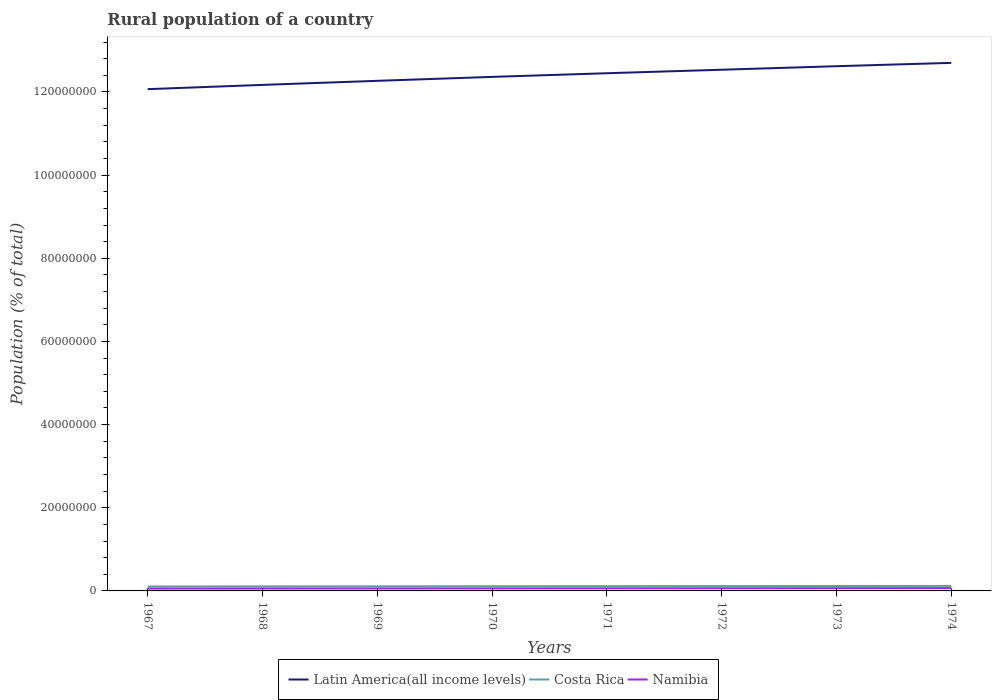How many different coloured lines are there?
Your answer should be very brief. 3. Is the number of lines equal to the number of legend labels?
Offer a very short reply. Yes. Across all years, what is the maximum rural population in Latin America(all income levels)?
Offer a very short reply. 1.21e+08. In which year was the rural population in Costa Rica maximum?
Offer a very short reply. 1967. What is the total rural population in Costa Rica in the graph?
Offer a terse response. -7.58e+04. What is the difference between the highest and the second highest rural population in Costa Rica?
Keep it short and to the point. 1.39e+05. What is the difference between the highest and the lowest rural population in Costa Rica?
Provide a short and direct response. 4. How many years are there in the graph?
Ensure brevity in your answer.  8. What is the difference between two consecutive major ticks on the Y-axis?
Your response must be concise. 2.00e+07. Are the values on the major ticks of Y-axis written in scientific E-notation?
Make the answer very short. No. How are the legend labels stacked?
Ensure brevity in your answer.  Horizontal. What is the title of the graph?
Your answer should be very brief. Rural population of a country. Does "Egypt, Arab Rep." appear as one of the legend labels in the graph?
Your answer should be compact. No. What is the label or title of the Y-axis?
Ensure brevity in your answer.  Population (% of total). What is the Population (% of total) in Latin America(all income levels) in 1967?
Make the answer very short. 1.21e+08. What is the Population (% of total) of Costa Rica in 1967?
Your response must be concise. 1.07e+06. What is the Population (% of total) of Namibia in 1967?
Provide a short and direct response. 5.68e+05. What is the Population (% of total) of Latin America(all income levels) in 1968?
Offer a very short reply. 1.22e+08. What is the Population (% of total) in Costa Rica in 1968?
Give a very brief answer. 1.09e+06. What is the Population (% of total) of Namibia in 1968?
Your answer should be compact. 5.80e+05. What is the Population (% of total) of Latin America(all income levels) in 1969?
Make the answer very short. 1.23e+08. What is the Population (% of total) of Costa Rica in 1969?
Give a very brief answer. 1.11e+06. What is the Population (% of total) in Namibia in 1969?
Provide a short and direct response. 5.93e+05. What is the Population (% of total) in Latin America(all income levels) in 1970?
Ensure brevity in your answer.  1.24e+08. What is the Population (% of total) of Costa Rica in 1970?
Offer a terse response. 1.13e+06. What is the Population (% of total) of Namibia in 1970?
Make the answer very short. 6.06e+05. What is the Population (% of total) of Latin America(all income levels) in 1971?
Ensure brevity in your answer.  1.25e+08. What is the Population (% of total) of Costa Rica in 1971?
Provide a succinct answer. 1.15e+06. What is the Population (% of total) in Namibia in 1971?
Give a very brief answer. 6.23e+05. What is the Population (% of total) of Latin America(all income levels) in 1972?
Your answer should be very brief. 1.25e+08. What is the Population (% of total) in Costa Rica in 1972?
Your answer should be very brief. 1.17e+06. What is the Population (% of total) in Namibia in 1972?
Your response must be concise. 6.40e+05. What is the Population (% of total) in Latin America(all income levels) in 1973?
Provide a short and direct response. 1.26e+08. What is the Population (% of total) of Costa Rica in 1973?
Provide a succinct answer. 1.18e+06. What is the Population (% of total) of Namibia in 1973?
Offer a terse response. 6.58e+05. What is the Population (% of total) of Latin America(all income levels) in 1974?
Provide a short and direct response. 1.27e+08. What is the Population (% of total) of Costa Rica in 1974?
Keep it short and to the point. 1.21e+06. What is the Population (% of total) of Namibia in 1974?
Offer a very short reply. 6.75e+05. Across all years, what is the maximum Population (% of total) in Latin America(all income levels)?
Offer a terse response. 1.27e+08. Across all years, what is the maximum Population (% of total) of Costa Rica?
Make the answer very short. 1.21e+06. Across all years, what is the maximum Population (% of total) in Namibia?
Offer a very short reply. 6.75e+05. Across all years, what is the minimum Population (% of total) in Latin America(all income levels)?
Give a very brief answer. 1.21e+08. Across all years, what is the minimum Population (% of total) of Costa Rica?
Your answer should be compact. 1.07e+06. Across all years, what is the minimum Population (% of total) of Namibia?
Keep it short and to the point. 5.68e+05. What is the total Population (% of total) of Latin America(all income levels) in the graph?
Give a very brief answer. 9.92e+08. What is the total Population (% of total) of Costa Rica in the graph?
Offer a terse response. 9.11e+06. What is the total Population (% of total) of Namibia in the graph?
Provide a succinct answer. 4.94e+06. What is the difference between the Population (% of total) in Latin America(all income levels) in 1967 and that in 1968?
Keep it short and to the point. -1.03e+06. What is the difference between the Population (% of total) of Costa Rica in 1967 and that in 1968?
Provide a short and direct response. -2.22e+04. What is the difference between the Population (% of total) in Namibia in 1967 and that in 1968?
Give a very brief answer. -1.18e+04. What is the difference between the Population (% of total) of Latin America(all income levels) in 1967 and that in 1969?
Your answer should be very brief. -2.01e+06. What is the difference between the Population (% of total) of Costa Rica in 1967 and that in 1969?
Your answer should be compact. -4.34e+04. What is the difference between the Population (% of total) of Namibia in 1967 and that in 1969?
Your answer should be compact. -2.44e+04. What is the difference between the Population (% of total) of Latin America(all income levels) in 1967 and that in 1970?
Make the answer very short. -2.95e+06. What is the difference between the Population (% of total) of Costa Rica in 1967 and that in 1970?
Your response must be concise. -6.32e+04. What is the difference between the Population (% of total) of Namibia in 1967 and that in 1970?
Offer a very short reply. -3.82e+04. What is the difference between the Population (% of total) in Latin America(all income levels) in 1967 and that in 1971?
Your response must be concise. -3.83e+06. What is the difference between the Population (% of total) of Costa Rica in 1967 and that in 1971?
Keep it short and to the point. -8.18e+04. What is the difference between the Population (% of total) of Namibia in 1967 and that in 1971?
Keep it short and to the point. -5.46e+04. What is the difference between the Population (% of total) of Latin America(all income levels) in 1967 and that in 1972?
Offer a very short reply. -4.67e+06. What is the difference between the Population (% of total) of Costa Rica in 1967 and that in 1972?
Keep it short and to the point. -9.91e+04. What is the difference between the Population (% of total) of Namibia in 1967 and that in 1972?
Offer a very short reply. -7.21e+04. What is the difference between the Population (% of total) in Latin America(all income levels) in 1967 and that in 1973?
Provide a short and direct response. -5.52e+06. What is the difference between the Population (% of total) of Costa Rica in 1967 and that in 1973?
Your answer should be compact. -1.17e+05. What is the difference between the Population (% of total) in Namibia in 1967 and that in 1973?
Offer a terse response. -9.00e+04. What is the difference between the Population (% of total) in Latin America(all income levels) in 1967 and that in 1974?
Make the answer very short. -6.33e+06. What is the difference between the Population (% of total) in Costa Rica in 1967 and that in 1974?
Provide a succinct answer. -1.39e+05. What is the difference between the Population (% of total) of Namibia in 1967 and that in 1974?
Your answer should be very brief. -1.07e+05. What is the difference between the Population (% of total) of Latin America(all income levels) in 1968 and that in 1969?
Ensure brevity in your answer.  -9.79e+05. What is the difference between the Population (% of total) of Costa Rica in 1968 and that in 1969?
Your answer should be compact. -2.11e+04. What is the difference between the Population (% of total) in Namibia in 1968 and that in 1969?
Your response must be concise. -1.26e+04. What is the difference between the Population (% of total) of Latin America(all income levels) in 1968 and that in 1970?
Offer a very short reply. -1.93e+06. What is the difference between the Population (% of total) of Costa Rica in 1968 and that in 1970?
Ensure brevity in your answer.  -4.10e+04. What is the difference between the Population (% of total) in Namibia in 1968 and that in 1970?
Provide a succinct answer. -2.64e+04. What is the difference between the Population (% of total) in Latin America(all income levels) in 1968 and that in 1971?
Offer a terse response. -2.81e+06. What is the difference between the Population (% of total) in Costa Rica in 1968 and that in 1971?
Offer a very short reply. -5.95e+04. What is the difference between the Population (% of total) of Namibia in 1968 and that in 1971?
Your answer should be very brief. -4.29e+04. What is the difference between the Population (% of total) in Latin America(all income levels) in 1968 and that in 1972?
Your response must be concise. -3.65e+06. What is the difference between the Population (% of total) of Costa Rica in 1968 and that in 1972?
Your response must be concise. -7.69e+04. What is the difference between the Population (% of total) of Namibia in 1968 and that in 1972?
Make the answer very short. -6.04e+04. What is the difference between the Population (% of total) in Latin America(all income levels) in 1968 and that in 1973?
Your answer should be compact. -4.50e+06. What is the difference between the Population (% of total) in Costa Rica in 1968 and that in 1973?
Make the answer very short. -9.43e+04. What is the difference between the Population (% of total) in Namibia in 1968 and that in 1973?
Give a very brief answer. -7.82e+04. What is the difference between the Population (% of total) in Latin America(all income levels) in 1968 and that in 1974?
Provide a short and direct response. -5.30e+06. What is the difference between the Population (% of total) in Costa Rica in 1968 and that in 1974?
Offer a terse response. -1.17e+05. What is the difference between the Population (% of total) in Namibia in 1968 and that in 1974?
Give a very brief answer. -9.55e+04. What is the difference between the Population (% of total) in Latin America(all income levels) in 1969 and that in 1970?
Offer a terse response. -9.47e+05. What is the difference between the Population (% of total) in Costa Rica in 1969 and that in 1970?
Your answer should be very brief. -1.99e+04. What is the difference between the Population (% of total) of Namibia in 1969 and that in 1970?
Make the answer very short. -1.38e+04. What is the difference between the Population (% of total) of Latin America(all income levels) in 1969 and that in 1971?
Your answer should be very brief. -1.83e+06. What is the difference between the Population (% of total) of Costa Rica in 1969 and that in 1971?
Provide a short and direct response. -3.84e+04. What is the difference between the Population (% of total) of Namibia in 1969 and that in 1971?
Provide a succinct answer. -3.03e+04. What is the difference between the Population (% of total) of Latin America(all income levels) in 1969 and that in 1972?
Your answer should be compact. -2.67e+06. What is the difference between the Population (% of total) in Costa Rica in 1969 and that in 1972?
Give a very brief answer. -5.58e+04. What is the difference between the Population (% of total) in Namibia in 1969 and that in 1972?
Provide a short and direct response. -4.78e+04. What is the difference between the Population (% of total) of Latin America(all income levels) in 1969 and that in 1973?
Provide a short and direct response. -3.52e+06. What is the difference between the Population (% of total) in Costa Rica in 1969 and that in 1973?
Give a very brief answer. -7.32e+04. What is the difference between the Population (% of total) of Namibia in 1969 and that in 1973?
Your answer should be very brief. -6.56e+04. What is the difference between the Population (% of total) in Latin America(all income levels) in 1969 and that in 1974?
Your answer should be compact. -4.32e+06. What is the difference between the Population (% of total) in Costa Rica in 1969 and that in 1974?
Your answer should be very brief. -9.57e+04. What is the difference between the Population (% of total) in Namibia in 1969 and that in 1974?
Make the answer very short. -8.29e+04. What is the difference between the Population (% of total) in Latin America(all income levels) in 1970 and that in 1971?
Your answer should be compact. -8.80e+05. What is the difference between the Population (% of total) of Costa Rica in 1970 and that in 1971?
Keep it short and to the point. -1.85e+04. What is the difference between the Population (% of total) of Namibia in 1970 and that in 1971?
Your answer should be compact. -1.64e+04. What is the difference between the Population (% of total) of Latin America(all income levels) in 1970 and that in 1972?
Provide a succinct answer. -1.72e+06. What is the difference between the Population (% of total) of Costa Rica in 1970 and that in 1972?
Your answer should be very brief. -3.59e+04. What is the difference between the Population (% of total) in Namibia in 1970 and that in 1972?
Keep it short and to the point. -3.39e+04. What is the difference between the Population (% of total) of Latin America(all income levels) in 1970 and that in 1973?
Provide a short and direct response. -2.57e+06. What is the difference between the Population (% of total) of Costa Rica in 1970 and that in 1973?
Ensure brevity in your answer.  -5.34e+04. What is the difference between the Population (% of total) in Namibia in 1970 and that in 1973?
Your answer should be very brief. -5.18e+04. What is the difference between the Population (% of total) in Latin America(all income levels) in 1970 and that in 1974?
Your answer should be very brief. -3.37e+06. What is the difference between the Population (% of total) of Costa Rica in 1970 and that in 1974?
Provide a short and direct response. -7.58e+04. What is the difference between the Population (% of total) of Namibia in 1970 and that in 1974?
Your answer should be compact. -6.91e+04. What is the difference between the Population (% of total) in Latin America(all income levels) in 1971 and that in 1972?
Give a very brief answer. -8.41e+05. What is the difference between the Population (% of total) of Costa Rica in 1971 and that in 1972?
Offer a terse response. -1.73e+04. What is the difference between the Population (% of total) of Namibia in 1971 and that in 1972?
Give a very brief answer. -1.75e+04. What is the difference between the Population (% of total) in Latin America(all income levels) in 1971 and that in 1973?
Your response must be concise. -1.69e+06. What is the difference between the Population (% of total) of Costa Rica in 1971 and that in 1973?
Give a very brief answer. -3.48e+04. What is the difference between the Population (% of total) in Namibia in 1971 and that in 1973?
Provide a succinct answer. -3.54e+04. What is the difference between the Population (% of total) of Latin America(all income levels) in 1971 and that in 1974?
Give a very brief answer. -2.49e+06. What is the difference between the Population (% of total) in Costa Rica in 1971 and that in 1974?
Keep it short and to the point. -5.73e+04. What is the difference between the Population (% of total) in Namibia in 1971 and that in 1974?
Your answer should be compact. -5.26e+04. What is the difference between the Population (% of total) in Latin America(all income levels) in 1972 and that in 1973?
Your answer should be compact. -8.50e+05. What is the difference between the Population (% of total) of Costa Rica in 1972 and that in 1973?
Your answer should be compact. -1.75e+04. What is the difference between the Population (% of total) of Namibia in 1972 and that in 1973?
Your answer should be very brief. -1.79e+04. What is the difference between the Population (% of total) of Latin America(all income levels) in 1972 and that in 1974?
Ensure brevity in your answer.  -1.65e+06. What is the difference between the Population (% of total) of Costa Rica in 1972 and that in 1974?
Provide a short and direct response. -3.99e+04. What is the difference between the Population (% of total) in Namibia in 1972 and that in 1974?
Keep it short and to the point. -3.51e+04. What is the difference between the Population (% of total) in Latin America(all income levels) in 1973 and that in 1974?
Offer a very short reply. -8.03e+05. What is the difference between the Population (% of total) in Costa Rica in 1973 and that in 1974?
Make the answer very short. -2.25e+04. What is the difference between the Population (% of total) of Namibia in 1973 and that in 1974?
Offer a terse response. -1.72e+04. What is the difference between the Population (% of total) of Latin America(all income levels) in 1967 and the Population (% of total) of Costa Rica in 1968?
Your response must be concise. 1.20e+08. What is the difference between the Population (% of total) in Latin America(all income levels) in 1967 and the Population (% of total) in Namibia in 1968?
Your response must be concise. 1.20e+08. What is the difference between the Population (% of total) of Costa Rica in 1967 and the Population (% of total) of Namibia in 1968?
Provide a short and direct response. 4.88e+05. What is the difference between the Population (% of total) in Latin America(all income levels) in 1967 and the Population (% of total) in Costa Rica in 1969?
Give a very brief answer. 1.20e+08. What is the difference between the Population (% of total) of Latin America(all income levels) in 1967 and the Population (% of total) of Namibia in 1969?
Your answer should be compact. 1.20e+08. What is the difference between the Population (% of total) in Costa Rica in 1967 and the Population (% of total) in Namibia in 1969?
Offer a very short reply. 4.75e+05. What is the difference between the Population (% of total) of Latin America(all income levels) in 1967 and the Population (% of total) of Costa Rica in 1970?
Provide a succinct answer. 1.20e+08. What is the difference between the Population (% of total) in Latin America(all income levels) in 1967 and the Population (% of total) in Namibia in 1970?
Provide a short and direct response. 1.20e+08. What is the difference between the Population (% of total) in Costa Rica in 1967 and the Population (% of total) in Namibia in 1970?
Keep it short and to the point. 4.61e+05. What is the difference between the Population (% of total) in Latin America(all income levels) in 1967 and the Population (% of total) in Costa Rica in 1971?
Your answer should be very brief. 1.20e+08. What is the difference between the Population (% of total) of Latin America(all income levels) in 1967 and the Population (% of total) of Namibia in 1971?
Provide a short and direct response. 1.20e+08. What is the difference between the Population (% of total) of Costa Rica in 1967 and the Population (% of total) of Namibia in 1971?
Your answer should be compact. 4.45e+05. What is the difference between the Population (% of total) of Latin America(all income levels) in 1967 and the Population (% of total) of Costa Rica in 1972?
Ensure brevity in your answer.  1.20e+08. What is the difference between the Population (% of total) of Latin America(all income levels) in 1967 and the Population (% of total) of Namibia in 1972?
Offer a very short reply. 1.20e+08. What is the difference between the Population (% of total) of Costa Rica in 1967 and the Population (% of total) of Namibia in 1972?
Give a very brief answer. 4.27e+05. What is the difference between the Population (% of total) in Latin America(all income levels) in 1967 and the Population (% of total) in Costa Rica in 1973?
Your response must be concise. 1.19e+08. What is the difference between the Population (% of total) of Latin America(all income levels) in 1967 and the Population (% of total) of Namibia in 1973?
Provide a succinct answer. 1.20e+08. What is the difference between the Population (% of total) in Costa Rica in 1967 and the Population (% of total) in Namibia in 1973?
Offer a terse response. 4.10e+05. What is the difference between the Population (% of total) in Latin America(all income levels) in 1967 and the Population (% of total) in Costa Rica in 1974?
Ensure brevity in your answer.  1.19e+08. What is the difference between the Population (% of total) of Latin America(all income levels) in 1967 and the Population (% of total) of Namibia in 1974?
Provide a short and direct response. 1.20e+08. What is the difference between the Population (% of total) in Costa Rica in 1967 and the Population (% of total) in Namibia in 1974?
Provide a short and direct response. 3.92e+05. What is the difference between the Population (% of total) of Latin America(all income levels) in 1968 and the Population (% of total) of Costa Rica in 1969?
Give a very brief answer. 1.21e+08. What is the difference between the Population (% of total) in Latin America(all income levels) in 1968 and the Population (% of total) in Namibia in 1969?
Your answer should be very brief. 1.21e+08. What is the difference between the Population (% of total) of Costa Rica in 1968 and the Population (% of total) of Namibia in 1969?
Your answer should be very brief. 4.97e+05. What is the difference between the Population (% of total) in Latin America(all income levels) in 1968 and the Population (% of total) in Costa Rica in 1970?
Give a very brief answer. 1.21e+08. What is the difference between the Population (% of total) of Latin America(all income levels) in 1968 and the Population (% of total) of Namibia in 1970?
Your answer should be very brief. 1.21e+08. What is the difference between the Population (% of total) of Costa Rica in 1968 and the Population (% of total) of Namibia in 1970?
Give a very brief answer. 4.84e+05. What is the difference between the Population (% of total) of Latin America(all income levels) in 1968 and the Population (% of total) of Costa Rica in 1971?
Keep it short and to the point. 1.21e+08. What is the difference between the Population (% of total) in Latin America(all income levels) in 1968 and the Population (% of total) in Namibia in 1971?
Provide a succinct answer. 1.21e+08. What is the difference between the Population (% of total) of Costa Rica in 1968 and the Population (% of total) of Namibia in 1971?
Your answer should be very brief. 4.67e+05. What is the difference between the Population (% of total) in Latin America(all income levels) in 1968 and the Population (% of total) in Costa Rica in 1972?
Your answer should be very brief. 1.21e+08. What is the difference between the Population (% of total) of Latin America(all income levels) in 1968 and the Population (% of total) of Namibia in 1972?
Ensure brevity in your answer.  1.21e+08. What is the difference between the Population (% of total) of Costa Rica in 1968 and the Population (% of total) of Namibia in 1972?
Give a very brief answer. 4.50e+05. What is the difference between the Population (% of total) of Latin America(all income levels) in 1968 and the Population (% of total) of Costa Rica in 1973?
Offer a terse response. 1.21e+08. What is the difference between the Population (% of total) of Latin America(all income levels) in 1968 and the Population (% of total) of Namibia in 1973?
Offer a very short reply. 1.21e+08. What is the difference between the Population (% of total) in Costa Rica in 1968 and the Population (% of total) in Namibia in 1973?
Your answer should be compact. 4.32e+05. What is the difference between the Population (% of total) in Latin America(all income levels) in 1968 and the Population (% of total) in Costa Rica in 1974?
Provide a succinct answer. 1.20e+08. What is the difference between the Population (% of total) of Latin America(all income levels) in 1968 and the Population (% of total) of Namibia in 1974?
Provide a short and direct response. 1.21e+08. What is the difference between the Population (% of total) of Costa Rica in 1968 and the Population (% of total) of Namibia in 1974?
Make the answer very short. 4.15e+05. What is the difference between the Population (% of total) in Latin America(all income levels) in 1969 and the Population (% of total) in Costa Rica in 1970?
Your answer should be very brief. 1.22e+08. What is the difference between the Population (% of total) in Latin America(all income levels) in 1969 and the Population (% of total) in Namibia in 1970?
Offer a terse response. 1.22e+08. What is the difference between the Population (% of total) of Costa Rica in 1969 and the Population (% of total) of Namibia in 1970?
Keep it short and to the point. 5.05e+05. What is the difference between the Population (% of total) in Latin America(all income levels) in 1969 and the Population (% of total) in Costa Rica in 1971?
Give a very brief answer. 1.22e+08. What is the difference between the Population (% of total) of Latin America(all income levels) in 1969 and the Population (% of total) of Namibia in 1971?
Ensure brevity in your answer.  1.22e+08. What is the difference between the Population (% of total) in Costa Rica in 1969 and the Population (% of total) in Namibia in 1971?
Offer a terse response. 4.88e+05. What is the difference between the Population (% of total) of Latin America(all income levels) in 1969 and the Population (% of total) of Costa Rica in 1972?
Your answer should be compact. 1.22e+08. What is the difference between the Population (% of total) of Latin America(all income levels) in 1969 and the Population (% of total) of Namibia in 1972?
Provide a short and direct response. 1.22e+08. What is the difference between the Population (% of total) in Costa Rica in 1969 and the Population (% of total) in Namibia in 1972?
Keep it short and to the point. 4.71e+05. What is the difference between the Population (% of total) of Latin America(all income levels) in 1969 and the Population (% of total) of Costa Rica in 1973?
Offer a very short reply. 1.21e+08. What is the difference between the Population (% of total) of Latin America(all income levels) in 1969 and the Population (% of total) of Namibia in 1973?
Keep it short and to the point. 1.22e+08. What is the difference between the Population (% of total) in Costa Rica in 1969 and the Population (% of total) in Namibia in 1973?
Ensure brevity in your answer.  4.53e+05. What is the difference between the Population (% of total) in Latin America(all income levels) in 1969 and the Population (% of total) in Costa Rica in 1974?
Provide a succinct answer. 1.21e+08. What is the difference between the Population (% of total) of Latin America(all income levels) in 1969 and the Population (% of total) of Namibia in 1974?
Give a very brief answer. 1.22e+08. What is the difference between the Population (% of total) of Costa Rica in 1969 and the Population (% of total) of Namibia in 1974?
Your answer should be compact. 4.36e+05. What is the difference between the Population (% of total) in Latin America(all income levels) in 1970 and the Population (% of total) in Costa Rica in 1971?
Ensure brevity in your answer.  1.22e+08. What is the difference between the Population (% of total) in Latin America(all income levels) in 1970 and the Population (% of total) in Namibia in 1971?
Offer a very short reply. 1.23e+08. What is the difference between the Population (% of total) of Costa Rica in 1970 and the Population (% of total) of Namibia in 1971?
Keep it short and to the point. 5.08e+05. What is the difference between the Population (% of total) of Latin America(all income levels) in 1970 and the Population (% of total) of Costa Rica in 1972?
Give a very brief answer. 1.22e+08. What is the difference between the Population (% of total) in Latin America(all income levels) in 1970 and the Population (% of total) in Namibia in 1972?
Provide a succinct answer. 1.23e+08. What is the difference between the Population (% of total) in Costa Rica in 1970 and the Population (% of total) in Namibia in 1972?
Give a very brief answer. 4.91e+05. What is the difference between the Population (% of total) of Latin America(all income levels) in 1970 and the Population (% of total) of Costa Rica in 1973?
Your answer should be very brief. 1.22e+08. What is the difference between the Population (% of total) of Latin America(all income levels) in 1970 and the Population (% of total) of Namibia in 1973?
Offer a terse response. 1.23e+08. What is the difference between the Population (% of total) in Costa Rica in 1970 and the Population (% of total) in Namibia in 1973?
Ensure brevity in your answer.  4.73e+05. What is the difference between the Population (% of total) of Latin America(all income levels) in 1970 and the Population (% of total) of Costa Rica in 1974?
Offer a terse response. 1.22e+08. What is the difference between the Population (% of total) of Latin America(all income levels) in 1970 and the Population (% of total) of Namibia in 1974?
Ensure brevity in your answer.  1.23e+08. What is the difference between the Population (% of total) in Costa Rica in 1970 and the Population (% of total) in Namibia in 1974?
Provide a short and direct response. 4.56e+05. What is the difference between the Population (% of total) of Latin America(all income levels) in 1971 and the Population (% of total) of Costa Rica in 1972?
Your answer should be compact. 1.23e+08. What is the difference between the Population (% of total) in Latin America(all income levels) in 1971 and the Population (% of total) in Namibia in 1972?
Make the answer very short. 1.24e+08. What is the difference between the Population (% of total) in Costa Rica in 1971 and the Population (% of total) in Namibia in 1972?
Provide a short and direct response. 5.09e+05. What is the difference between the Population (% of total) in Latin America(all income levels) in 1971 and the Population (% of total) in Costa Rica in 1973?
Give a very brief answer. 1.23e+08. What is the difference between the Population (% of total) in Latin America(all income levels) in 1971 and the Population (% of total) in Namibia in 1973?
Provide a short and direct response. 1.24e+08. What is the difference between the Population (% of total) in Costa Rica in 1971 and the Population (% of total) in Namibia in 1973?
Give a very brief answer. 4.91e+05. What is the difference between the Population (% of total) of Latin America(all income levels) in 1971 and the Population (% of total) of Costa Rica in 1974?
Give a very brief answer. 1.23e+08. What is the difference between the Population (% of total) in Latin America(all income levels) in 1971 and the Population (% of total) in Namibia in 1974?
Ensure brevity in your answer.  1.24e+08. What is the difference between the Population (% of total) of Costa Rica in 1971 and the Population (% of total) of Namibia in 1974?
Your answer should be compact. 4.74e+05. What is the difference between the Population (% of total) of Latin America(all income levels) in 1972 and the Population (% of total) of Costa Rica in 1973?
Give a very brief answer. 1.24e+08. What is the difference between the Population (% of total) of Latin America(all income levels) in 1972 and the Population (% of total) of Namibia in 1973?
Your response must be concise. 1.25e+08. What is the difference between the Population (% of total) in Costa Rica in 1972 and the Population (% of total) in Namibia in 1973?
Ensure brevity in your answer.  5.09e+05. What is the difference between the Population (% of total) of Latin America(all income levels) in 1972 and the Population (% of total) of Costa Rica in 1974?
Offer a very short reply. 1.24e+08. What is the difference between the Population (% of total) in Latin America(all income levels) in 1972 and the Population (% of total) in Namibia in 1974?
Provide a short and direct response. 1.25e+08. What is the difference between the Population (% of total) of Costa Rica in 1972 and the Population (% of total) of Namibia in 1974?
Make the answer very short. 4.91e+05. What is the difference between the Population (% of total) of Latin America(all income levels) in 1973 and the Population (% of total) of Costa Rica in 1974?
Provide a short and direct response. 1.25e+08. What is the difference between the Population (% of total) of Latin America(all income levels) in 1973 and the Population (% of total) of Namibia in 1974?
Offer a terse response. 1.26e+08. What is the difference between the Population (% of total) in Costa Rica in 1973 and the Population (% of total) in Namibia in 1974?
Your answer should be very brief. 5.09e+05. What is the average Population (% of total) in Latin America(all income levels) per year?
Your answer should be compact. 1.24e+08. What is the average Population (% of total) of Costa Rica per year?
Your answer should be compact. 1.14e+06. What is the average Population (% of total) in Namibia per year?
Provide a succinct answer. 6.18e+05. In the year 1967, what is the difference between the Population (% of total) of Latin America(all income levels) and Population (% of total) of Costa Rica?
Provide a short and direct response. 1.20e+08. In the year 1967, what is the difference between the Population (% of total) of Latin America(all income levels) and Population (% of total) of Namibia?
Keep it short and to the point. 1.20e+08. In the year 1967, what is the difference between the Population (% of total) of Costa Rica and Population (% of total) of Namibia?
Provide a short and direct response. 5.00e+05. In the year 1968, what is the difference between the Population (% of total) of Latin America(all income levels) and Population (% of total) of Costa Rica?
Make the answer very short. 1.21e+08. In the year 1968, what is the difference between the Population (% of total) of Latin America(all income levels) and Population (% of total) of Namibia?
Your response must be concise. 1.21e+08. In the year 1968, what is the difference between the Population (% of total) in Costa Rica and Population (% of total) in Namibia?
Make the answer very short. 5.10e+05. In the year 1969, what is the difference between the Population (% of total) in Latin America(all income levels) and Population (% of total) in Costa Rica?
Your answer should be compact. 1.22e+08. In the year 1969, what is the difference between the Population (% of total) in Latin America(all income levels) and Population (% of total) in Namibia?
Offer a terse response. 1.22e+08. In the year 1969, what is the difference between the Population (% of total) in Costa Rica and Population (% of total) in Namibia?
Make the answer very short. 5.19e+05. In the year 1970, what is the difference between the Population (% of total) in Latin America(all income levels) and Population (% of total) in Costa Rica?
Give a very brief answer. 1.22e+08. In the year 1970, what is the difference between the Population (% of total) of Latin America(all income levels) and Population (% of total) of Namibia?
Your response must be concise. 1.23e+08. In the year 1970, what is the difference between the Population (% of total) in Costa Rica and Population (% of total) in Namibia?
Give a very brief answer. 5.25e+05. In the year 1971, what is the difference between the Population (% of total) of Latin America(all income levels) and Population (% of total) of Costa Rica?
Make the answer very short. 1.23e+08. In the year 1971, what is the difference between the Population (% of total) of Latin America(all income levels) and Population (% of total) of Namibia?
Offer a very short reply. 1.24e+08. In the year 1971, what is the difference between the Population (% of total) in Costa Rica and Population (% of total) in Namibia?
Your answer should be compact. 5.27e+05. In the year 1972, what is the difference between the Population (% of total) of Latin America(all income levels) and Population (% of total) of Costa Rica?
Provide a short and direct response. 1.24e+08. In the year 1972, what is the difference between the Population (% of total) of Latin America(all income levels) and Population (% of total) of Namibia?
Ensure brevity in your answer.  1.25e+08. In the year 1972, what is the difference between the Population (% of total) of Costa Rica and Population (% of total) of Namibia?
Keep it short and to the point. 5.27e+05. In the year 1973, what is the difference between the Population (% of total) in Latin America(all income levels) and Population (% of total) in Costa Rica?
Your response must be concise. 1.25e+08. In the year 1973, what is the difference between the Population (% of total) of Latin America(all income levels) and Population (% of total) of Namibia?
Your answer should be very brief. 1.26e+08. In the year 1973, what is the difference between the Population (% of total) of Costa Rica and Population (% of total) of Namibia?
Provide a succinct answer. 5.26e+05. In the year 1974, what is the difference between the Population (% of total) of Latin America(all income levels) and Population (% of total) of Costa Rica?
Offer a very short reply. 1.26e+08. In the year 1974, what is the difference between the Population (% of total) in Latin America(all income levels) and Population (% of total) in Namibia?
Make the answer very short. 1.26e+08. In the year 1974, what is the difference between the Population (% of total) in Costa Rica and Population (% of total) in Namibia?
Your answer should be compact. 5.31e+05. What is the ratio of the Population (% of total) in Costa Rica in 1967 to that in 1968?
Give a very brief answer. 0.98. What is the ratio of the Population (% of total) of Namibia in 1967 to that in 1968?
Provide a short and direct response. 0.98. What is the ratio of the Population (% of total) of Latin America(all income levels) in 1967 to that in 1969?
Provide a short and direct response. 0.98. What is the ratio of the Population (% of total) of Costa Rica in 1967 to that in 1969?
Provide a succinct answer. 0.96. What is the ratio of the Population (% of total) of Namibia in 1967 to that in 1969?
Keep it short and to the point. 0.96. What is the ratio of the Population (% of total) of Latin America(all income levels) in 1967 to that in 1970?
Your response must be concise. 0.98. What is the ratio of the Population (% of total) in Costa Rica in 1967 to that in 1970?
Offer a terse response. 0.94. What is the ratio of the Population (% of total) of Namibia in 1967 to that in 1970?
Make the answer very short. 0.94. What is the ratio of the Population (% of total) in Latin America(all income levels) in 1967 to that in 1971?
Offer a very short reply. 0.97. What is the ratio of the Population (% of total) in Costa Rica in 1967 to that in 1971?
Give a very brief answer. 0.93. What is the ratio of the Population (% of total) of Namibia in 1967 to that in 1971?
Offer a terse response. 0.91. What is the ratio of the Population (% of total) of Latin America(all income levels) in 1967 to that in 1972?
Your answer should be compact. 0.96. What is the ratio of the Population (% of total) in Costa Rica in 1967 to that in 1972?
Keep it short and to the point. 0.92. What is the ratio of the Population (% of total) in Namibia in 1967 to that in 1972?
Your answer should be very brief. 0.89. What is the ratio of the Population (% of total) of Latin America(all income levels) in 1967 to that in 1973?
Offer a terse response. 0.96. What is the ratio of the Population (% of total) of Costa Rica in 1967 to that in 1973?
Your answer should be very brief. 0.9. What is the ratio of the Population (% of total) in Namibia in 1967 to that in 1973?
Give a very brief answer. 0.86. What is the ratio of the Population (% of total) in Latin America(all income levels) in 1967 to that in 1974?
Your response must be concise. 0.95. What is the ratio of the Population (% of total) in Costa Rica in 1967 to that in 1974?
Keep it short and to the point. 0.88. What is the ratio of the Population (% of total) in Namibia in 1967 to that in 1974?
Make the answer very short. 0.84. What is the ratio of the Population (% of total) of Namibia in 1968 to that in 1969?
Your response must be concise. 0.98. What is the ratio of the Population (% of total) in Latin America(all income levels) in 1968 to that in 1970?
Make the answer very short. 0.98. What is the ratio of the Population (% of total) in Costa Rica in 1968 to that in 1970?
Your response must be concise. 0.96. What is the ratio of the Population (% of total) in Namibia in 1968 to that in 1970?
Provide a short and direct response. 0.96. What is the ratio of the Population (% of total) in Latin America(all income levels) in 1968 to that in 1971?
Provide a succinct answer. 0.98. What is the ratio of the Population (% of total) in Costa Rica in 1968 to that in 1971?
Keep it short and to the point. 0.95. What is the ratio of the Population (% of total) in Namibia in 1968 to that in 1971?
Offer a terse response. 0.93. What is the ratio of the Population (% of total) in Latin America(all income levels) in 1968 to that in 1972?
Ensure brevity in your answer.  0.97. What is the ratio of the Population (% of total) in Costa Rica in 1968 to that in 1972?
Make the answer very short. 0.93. What is the ratio of the Population (% of total) in Namibia in 1968 to that in 1972?
Provide a succinct answer. 0.91. What is the ratio of the Population (% of total) in Latin America(all income levels) in 1968 to that in 1973?
Ensure brevity in your answer.  0.96. What is the ratio of the Population (% of total) in Costa Rica in 1968 to that in 1973?
Your answer should be compact. 0.92. What is the ratio of the Population (% of total) in Namibia in 1968 to that in 1973?
Your answer should be compact. 0.88. What is the ratio of the Population (% of total) in Costa Rica in 1968 to that in 1974?
Your answer should be compact. 0.9. What is the ratio of the Population (% of total) in Namibia in 1968 to that in 1974?
Your answer should be very brief. 0.86. What is the ratio of the Population (% of total) of Costa Rica in 1969 to that in 1970?
Provide a succinct answer. 0.98. What is the ratio of the Population (% of total) of Namibia in 1969 to that in 1970?
Make the answer very short. 0.98. What is the ratio of the Population (% of total) in Costa Rica in 1969 to that in 1971?
Provide a short and direct response. 0.97. What is the ratio of the Population (% of total) in Namibia in 1969 to that in 1971?
Your response must be concise. 0.95. What is the ratio of the Population (% of total) of Latin America(all income levels) in 1969 to that in 1972?
Provide a short and direct response. 0.98. What is the ratio of the Population (% of total) of Costa Rica in 1969 to that in 1972?
Make the answer very short. 0.95. What is the ratio of the Population (% of total) of Namibia in 1969 to that in 1972?
Make the answer very short. 0.93. What is the ratio of the Population (% of total) in Latin America(all income levels) in 1969 to that in 1973?
Offer a very short reply. 0.97. What is the ratio of the Population (% of total) in Costa Rica in 1969 to that in 1973?
Offer a terse response. 0.94. What is the ratio of the Population (% of total) in Namibia in 1969 to that in 1973?
Make the answer very short. 0.9. What is the ratio of the Population (% of total) in Latin America(all income levels) in 1969 to that in 1974?
Ensure brevity in your answer.  0.97. What is the ratio of the Population (% of total) in Costa Rica in 1969 to that in 1974?
Offer a very short reply. 0.92. What is the ratio of the Population (% of total) of Namibia in 1969 to that in 1974?
Provide a succinct answer. 0.88. What is the ratio of the Population (% of total) in Costa Rica in 1970 to that in 1971?
Offer a terse response. 0.98. What is the ratio of the Population (% of total) in Namibia in 1970 to that in 1971?
Your answer should be very brief. 0.97. What is the ratio of the Population (% of total) of Latin America(all income levels) in 1970 to that in 1972?
Your response must be concise. 0.99. What is the ratio of the Population (% of total) of Costa Rica in 1970 to that in 1972?
Offer a terse response. 0.97. What is the ratio of the Population (% of total) of Namibia in 1970 to that in 1972?
Give a very brief answer. 0.95. What is the ratio of the Population (% of total) in Latin America(all income levels) in 1970 to that in 1973?
Your answer should be very brief. 0.98. What is the ratio of the Population (% of total) of Costa Rica in 1970 to that in 1973?
Keep it short and to the point. 0.95. What is the ratio of the Population (% of total) of Namibia in 1970 to that in 1973?
Ensure brevity in your answer.  0.92. What is the ratio of the Population (% of total) of Latin America(all income levels) in 1970 to that in 1974?
Provide a short and direct response. 0.97. What is the ratio of the Population (% of total) of Costa Rica in 1970 to that in 1974?
Give a very brief answer. 0.94. What is the ratio of the Population (% of total) in Namibia in 1970 to that in 1974?
Your response must be concise. 0.9. What is the ratio of the Population (% of total) in Latin America(all income levels) in 1971 to that in 1972?
Make the answer very short. 0.99. What is the ratio of the Population (% of total) in Costa Rica in 1971 to that in 1972?
Ensure brevity in your answer.  0.99. What is the ratio of the Population (% of total) of Namibia in 1971 to that in 1972?
Your answer should be very brief. 0.97. What is the ratio of the Population (% of total) of Latin America(all income levels) in 1971 to that in 1973?
Ensure brevity in your answer.  0.99. What is the ratio of the Population (% of total) in Costa Rica in 1971 to that in 1973?
Make the answer very short. 0.97. What is the ratio of the Population (% of total) of Namibia in 1971 to that in 1973?
Offer a very short reply. 0.95. What is the ratio of the Population (% of total) in Latin America(all income levels) in 1971 to that in 1974?
Keep it short and to the point. 0.98. What is the ratio of the Population (% of total) of Costa Rica in 1971 to that in 1974?
Your response must be concise. 0.95. What is the ratio of the Population (% of total) in Namibia in 1971 to that in 1974?
Your response must be concise. 0.92. What is the ratio of the Population (% of total) in Latin America(all income levels) in 1972 to that in 1973?
Your answer should be very brief. 0.99. What is the ratio of the Population (% of total) of Costa Rica in 1972 to that in 1973?
Your answer should be compact. 0.99. What is the ratio of the Population (% of total) in Namibia in 1972 to that in 1973?
Give a very brief answer. 0.97. What is the ratio of the Population (% of total) in Costa Rica in 1972 to that in 1974?
Offer a terse response. 0.97. What is the ratio of the Population (% of total) in Namibia in 1972 to that in 1974?
Your response must be concise. 0.95. What is the ratio of the Population (% of total) of Latin America(all income levels) in 1973 to that in 1974?
Offer a terse response. 0.99. What is the ratio of the Population (% of total) of Costa Rica in 1973 to that in 1974?
Your response must be concise. 0.98. What is the ratio of the Population (% of total) in Namibia in 1973 to that in 1974?
Give a very brief answer. 0.97. What is the difference between the highest and the second highest Population (% of total) of Latin America(all income levels)?
Provide a short and direct response. 8.03e+05. What is the difference between the highest and the second highest Population (% of total) in Costa Rica?
Ensure brevity in your answer.  2.25e+04. What is the difference between the highest and the second highest Population (% of total) in Namibia?
Offer a very short reply. 1.72e+04. What is the difference between the highest and the lowest Population (% of total) in Latin America(all income levels)?
Offer a terse response. 6.33e+06. What is the difference between the highest and the lowest Population (% of total) of Costa Rica?
Your response must be concise. 1.39e+05. What is the difference between the highest and the lowest Population (% of total) of Namibia?
Provide a short and direct response. 1.07e+05. 